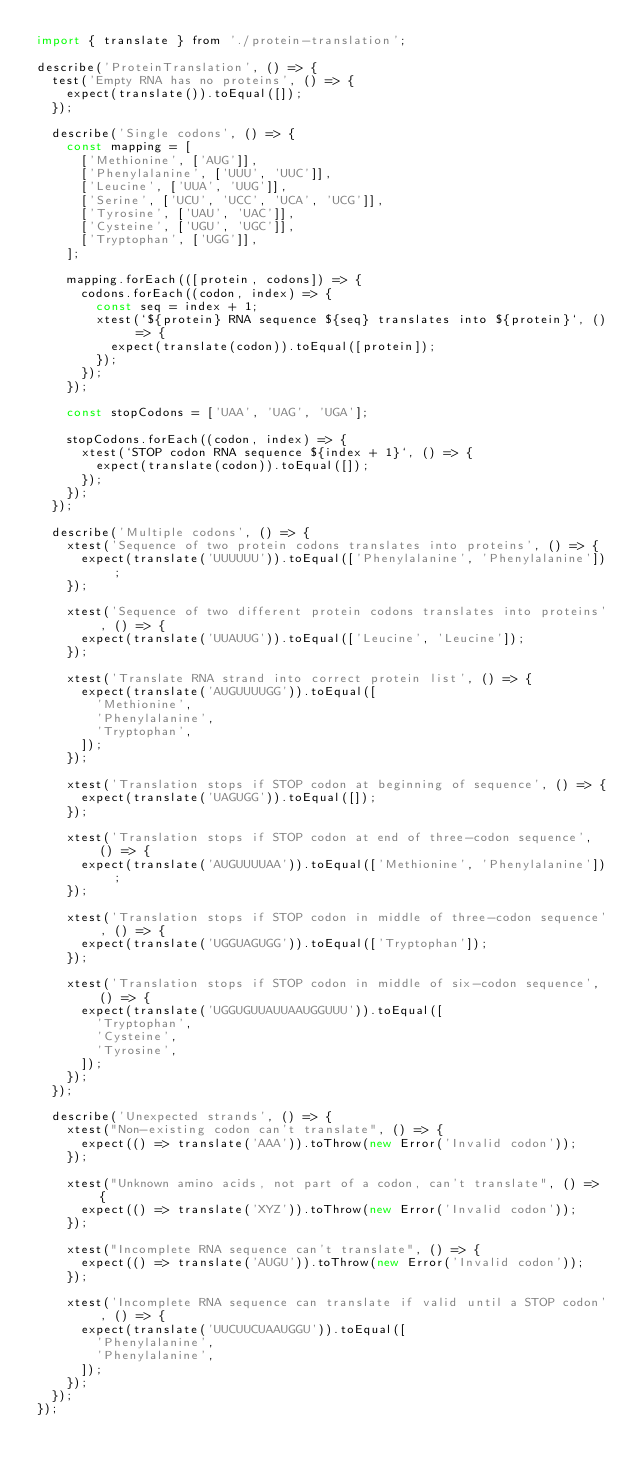<code> <loc_0><loc_0><loc_500><loc_500><_JavaScript_>import { translate } from './protein-translation';

describe('ProteinTranslation', () => {
  test('Empty RNA has no proteins', () => {
    expect(translate()).toEqual([]);
  });

  describe('Single codons', () => {
    const mapping = [
      ['Methionine', ['AUG']],
      ['Phenylalanine', ['UUU', 'UUC']],
      ['Leucine', ['UUA', 'UUG']],
      ['Serine', ['UCU', 'UCC', 'UCA', 'UCG']],
      ['Tyrosine', ['UAU', 'UAC']],
      ['Cysteine', ['UGU', 'UGC']],
      ['Tryptophan', ['UGG']],
    ];

    mapping.forEach(([protein, codons]) => {
      codons.forEach((codon, index) => {
        const seq = index + 1;
        xtest(`${protein} RNA sequence ${seq} translates into ${protein}`, () => {
          expect(translate(codon)).toEqual([protein]);
        });
      });
    });

    const stopCodons = ['UAA', 'UAG', 'UGA'];

    stopCodons.forEach((codon, index) => {
      xtest(`STOP codon RNA sequence ${index + 1}`, () => {
        expect(translate(codon)).toEqual([]);
      });
    });
  });

  describe('Multiple codons', () => {
    xtest('Sequence of two protein codons translates into proteins', () => {
      expect(translate('UUUUUU')).toEqual(['Phenylalanine', 'Phenylalanine']);
    });

    xtest('Sequence of two different protein codons translates into proteins', () => {
      expect(translate('UUAUUG')).toEqual(['Leucine', 'Leucine']);
    });

    xtest('Translate RNA strand into correct protein list', () => {
      expect(translate('AUGUUUUGG')).toEqual([
        'Methionine',
        'Phenylalanine',
        'Tryptophan',
      ]);
    });

    xtest('Translation stops if STOP codon at beginning of sequence', () => {
      expect(translate('UAGUGG')).toEqual([]);
    });

    xtest('Translation stops if STOP codon at end of three-codon sequence', () => {
      expect(translate('AUGUUUUAA')).toEqual(['Methionine', 'Phenylalanine']);
    });

    xtest('Translation stops if STOP codon in middle of three-codon sequence', () => {
      expect(translate('UGGUAGUGG')).toEqual(['Tryptophan']);
    });

    xtest('Translation stops if STOP codon in middle of six-codon sequence', () => {
      expect(translate('UGGUGUUAUUAAUGGUUU')).toEqual([
        'Tryptophan',
        'Cysteine',
        'Tyrosine',
      ]);
    });
  });

  describe('Unexpected strands', () => {
    xtest("Non-existing codon can't translate", () => {
      expect(() => translate('AAA')).toThrow(new Error('Invalid codon'));
    });

    xtest("Unknown amino acids, not part of a codon, can't translate", () => {
      expect(() => translate('XYZ')).toThrow(new Error('Invalid codon'));
    });

    xtest("Incomplete RNA sequence can't translate", () => {
      expect(() => translate('AUGU')).toThrow(new Error('Invalid codon'));
    });

    xtest('Incomplete RNA sequence can translate if valid until a STOP codon', () => {
      expect(translate('UUCUUCUAAUGGU')).toEqual([
        'Phenylalanine',
        'Phenylalanine',
      ]);
    });
  });
});
</code> 